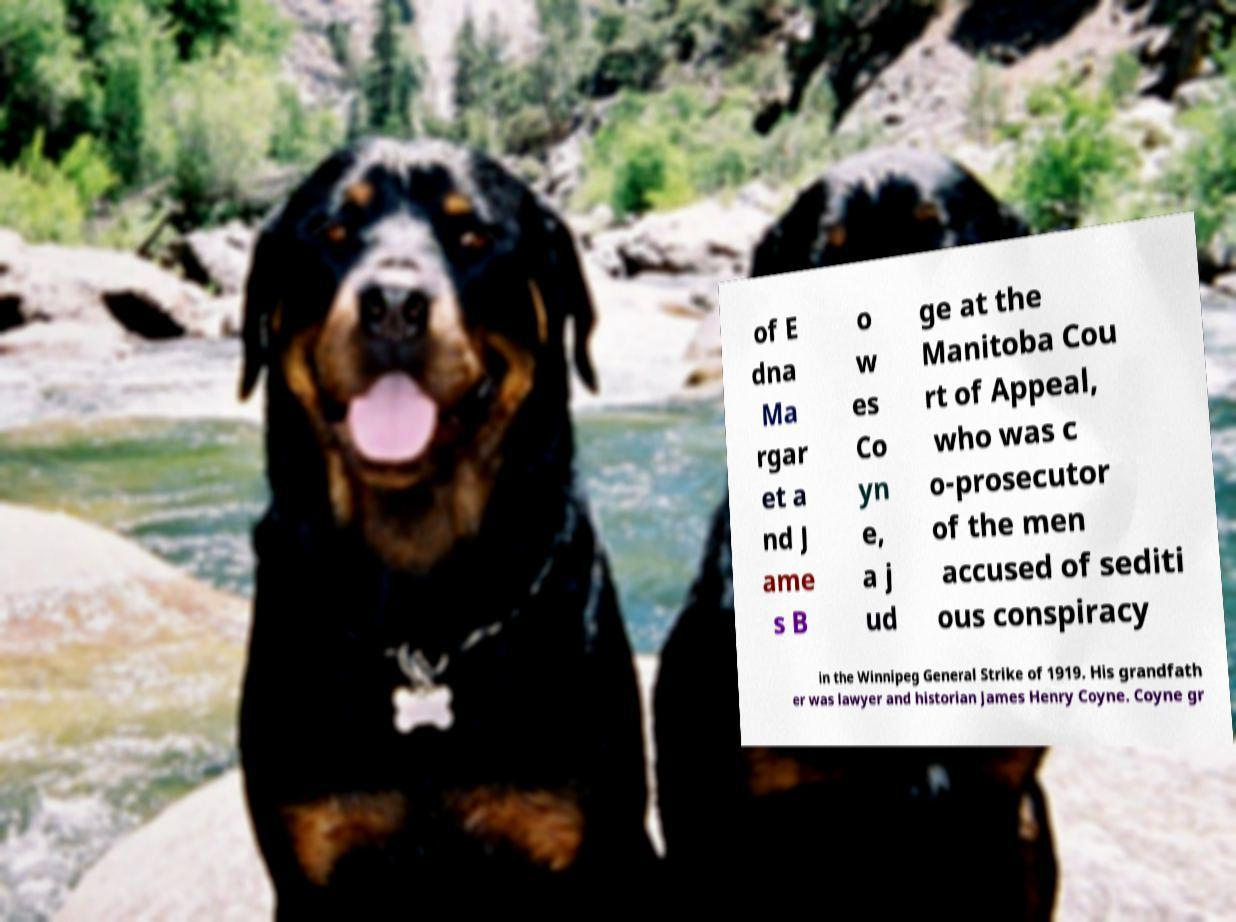Could you assist in decoding the text presented in this image and type it out clearly? of E dna Ma rgar et a nd J ame s B o w es Co yn e, a j ud ge at the Manitoba Cou rt of Appeal, who was c o-prosecutor of the men accused of sediti ous conspiracy in the Winnipeg General Strike of 1919. His grandfath er was lawyer and historian James Henry Coyne. Coyne gr 